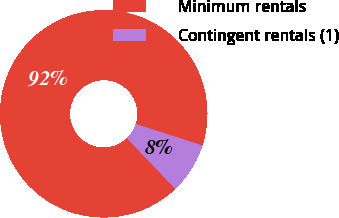Convert chart. <chart><loc_0><loc_0><loc_500><loc_500><pie_chart><fcel>Minimum rentals<fcel>Contingent rentals (1)<nl><fcel>92.06%<fcel>7.94%<nl></chart> 